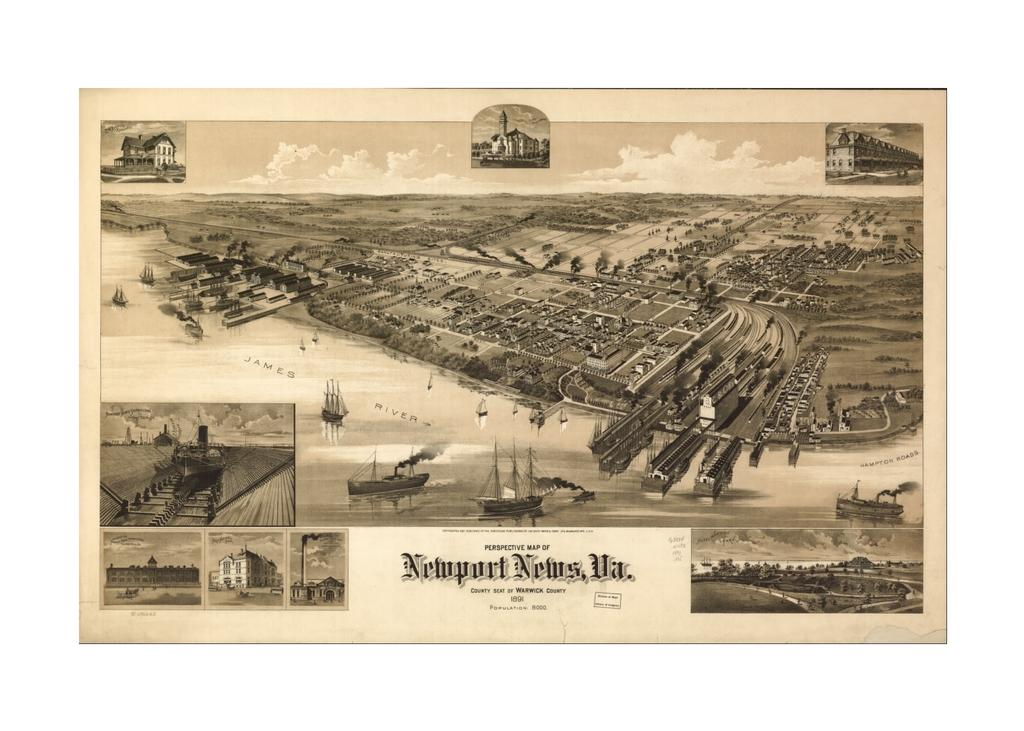<image>
Write a terse but informative summary of the picture. A Newport News image shows buildings by a waterway. 